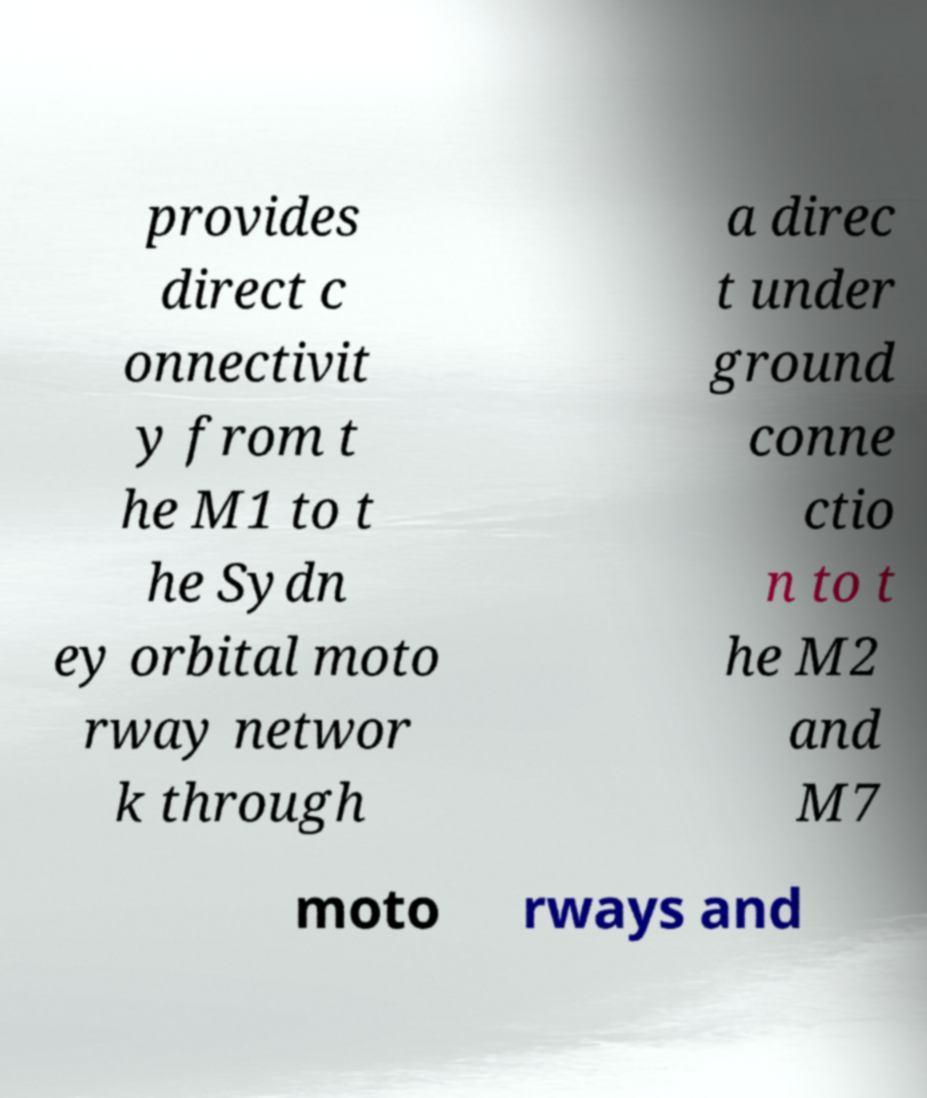Could you assist in decoding the text presented in this image and type it out clearly? provides direct c onnectivit y from t he M1 to t he Sydn ey orbital moto rway networ k through a direc t under ground conne ctio n to t he M2 and M7 moto rways and 